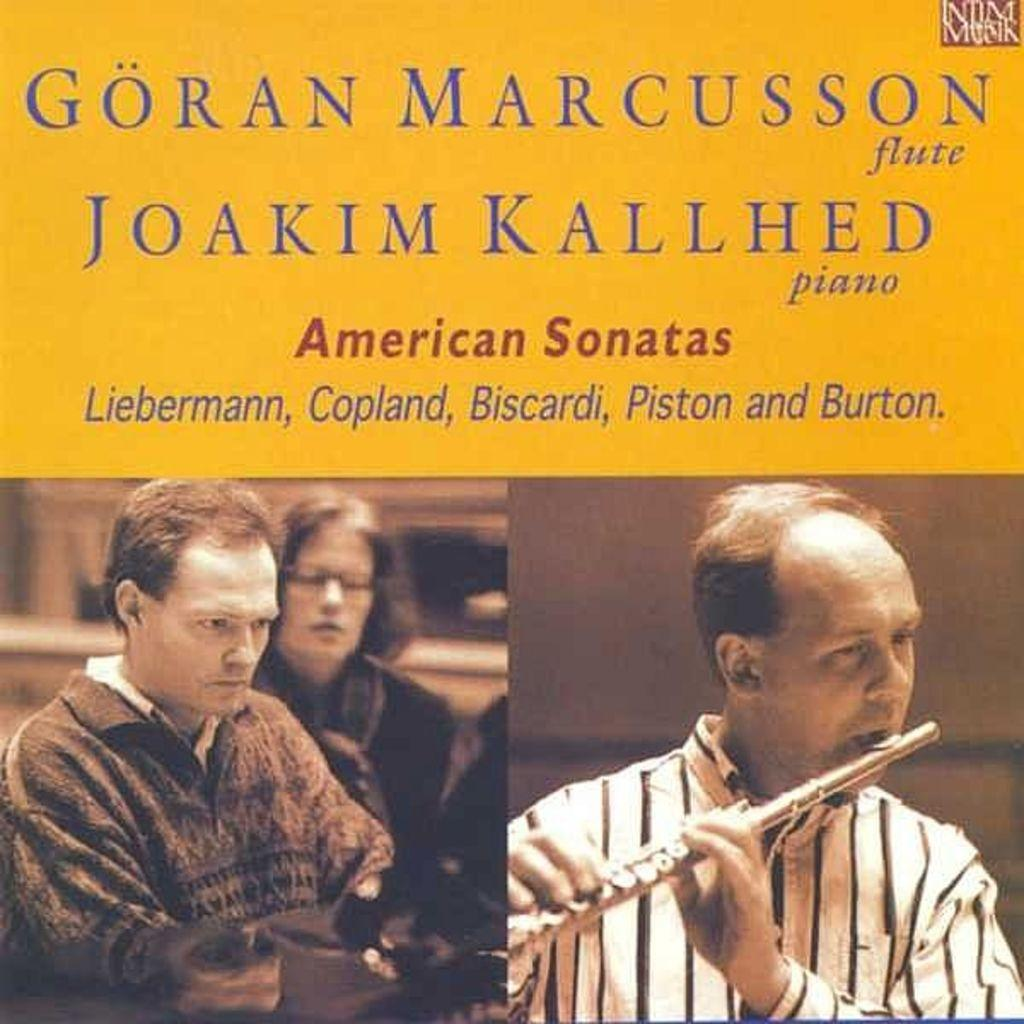What type of content does the image represent? The image is the cover page of a book. How many people are depicted on the cover? There are three persons in the image. What type of gold toothbrush is being used by the person on the left side of the image? There is no toothbrush or gold object present in the image. What type of celery is being held by the person in the middle of the image? There is no celery or any food item present in the image. 